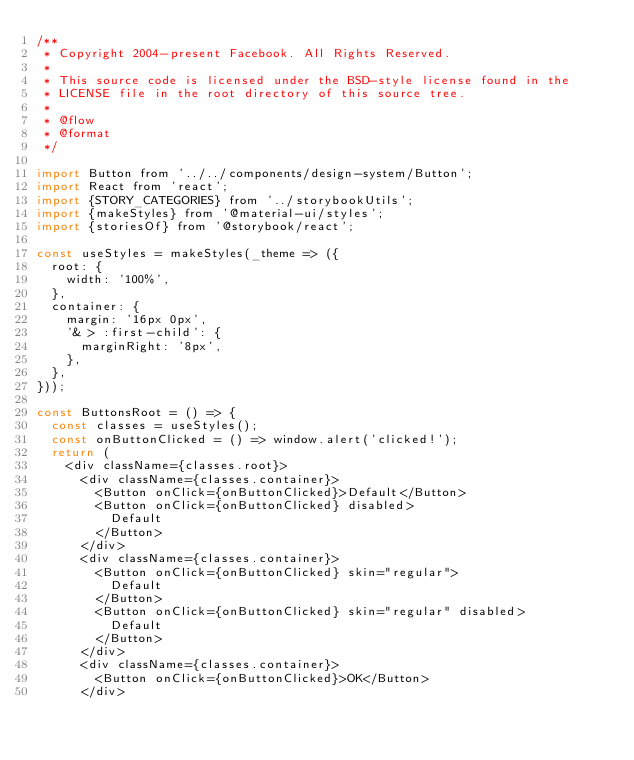<code> <loc_0><loc_0><loc_500><loc_500><_JavaScript_>/**
 * Copyright 2004-present Facebook. All Rights Reserved.
 *
 * This source code is licensed under the BSD-style license found in the
 * LICENSE file in the root directory of this source tree.
 *
 * @flow
 * @format
 */

import Button from '../../components/design-system/Button';
import React from 'react';
import {STORY_CATEGORIES} from '../storybookUtils';
import {makeStyles} from '@material-ui/styles';
import {storiesOf} from '@storybook/react';

const useStyles = makeStyles(_theme => ({
  root: {
    width: '100%',
  },
  container: {
    margin: '16px 0px',
    '& > :first-child': {
      marginRight: '8px',
    },
  },
}));

const ButtonsRoot = () => {
  const classes = useStyles();
  const onButtonClicked = () => window.alert('clicked!');
  return (
    <div className={classes.root}>
      <div className={classes.container}>
        <Button onClick={onButtonClicked}>Default</Button>
        <Button onClick={onButtonClicked} disabled>
          Default
        </Button>
      </div>
      <div className={classes.container}>
        <Button onClick={onButtonClicked} skin="regular">
          Default
        </Button>
        <Button onClick={onButtonClicked} skin="regular" disabled>
          Default
        </Button>
      </div>
      <div className={classes.container}>
        <Button onClick={onButtonClicked}>OK</Button>
      </div></code> 